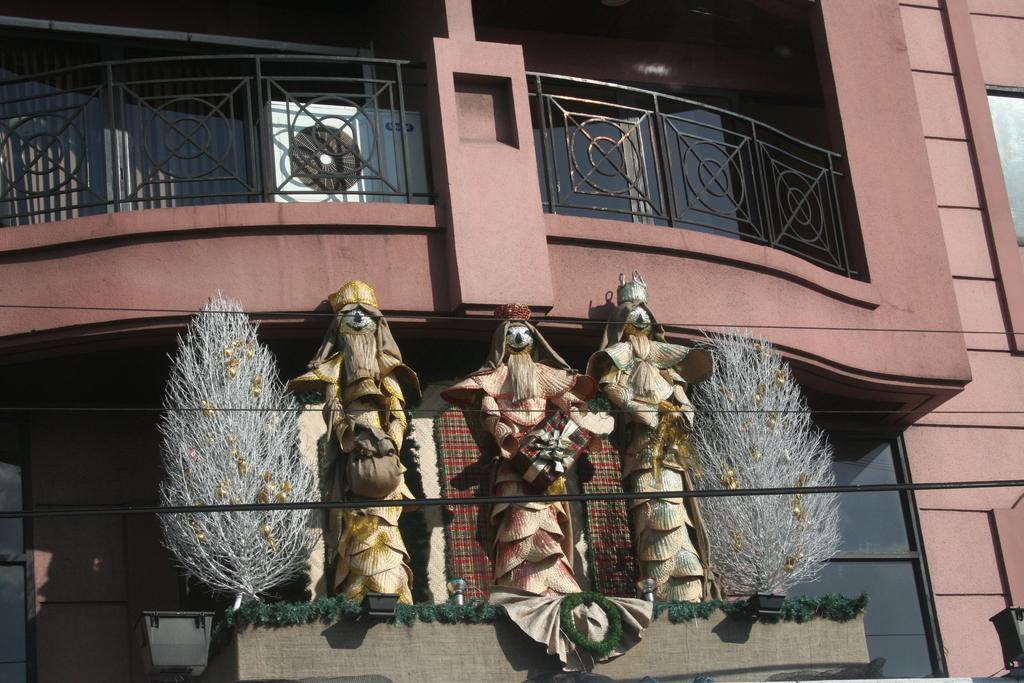Please provide a concise description of this image. In this image we can see building with glass walls and railing. In front of the building there are statues and plants. Also there are decorative items. 